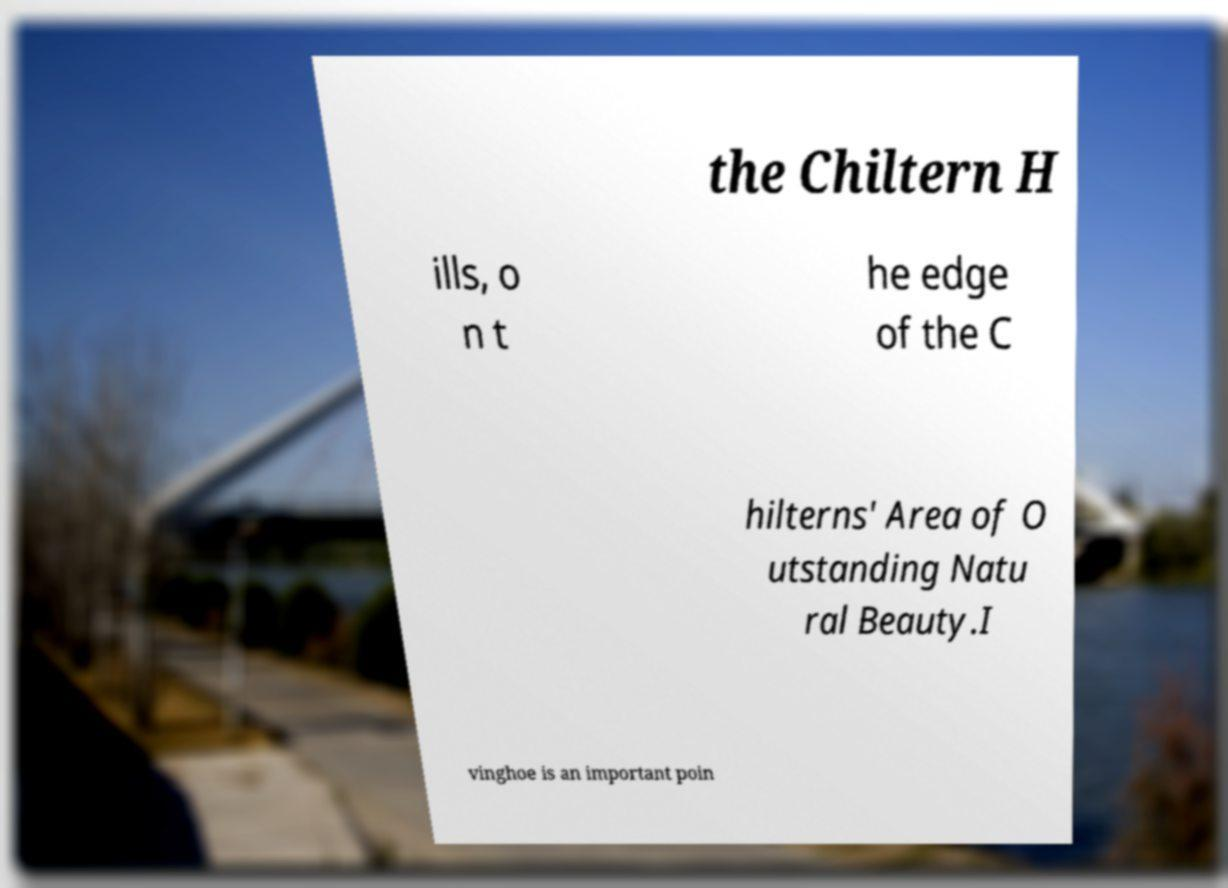Can you accurately transcribe the text from the provided image for me? the Chiltern H ills, o n t he edge of the C hilterns' Area of O utstanding Natu ral Beauty.I vinghoe is an important poin 